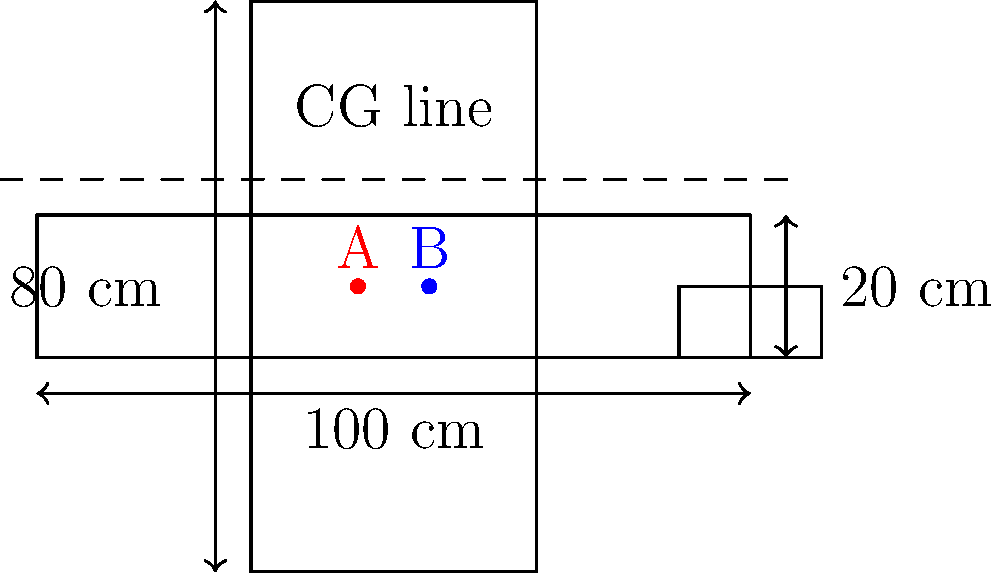In the diagram above, two potential center of gravity (CG) positions are marked for a model aircraft: point A (red) and point B (blue). The aircraft's total weight is 500 grams, with the wings contributing 200 grams. If the ideal CG should be at 45% of the chord (front-to-back length) for optimal flight characteristics, which point is closer to the ideal CG position? Calculate the difference between the two points in centimeters. To solve this problem, let's follow these steps:

1. Determine the ideal CG position:
   - The chord (front-to-back length) is 100 cm
   - Ideal CG should be at 45% of the chord
   - Ideal CG position = $100 \text{ cm} \times 0.45 = 45 \text{ cm}$ from the front

2. Identify the positions of points A and B:
   - Point A (red) is at 45 cm from the front
   - Point B (blue) is at 55 cm from the front

3. Calculate the difference between each point and the ideal CG:
   - Point A: $|45 \text{ cm} - 45 \text{ cm}| = 0 \text{ cm}$
   - Point B: $|55 \text{ cm} - 45 \text{ cm}| = 10 \text{ cm}$

4. Determine which point is closer to the ideal CG:
   Point A is exactly at the ideal CG position, while Point B is 10 cm behind it.

5. Calculate the difference between the two points:
   Distance between A and B = $55 \text{ cm} - 45 \text{ cm} = 10 \text{ cm}$

Therefore, Point A is closer to the ideal CG position, and the difference between the two points is 10 cm.
Answer: Point A; 10 cm 